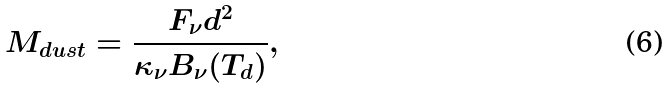Convert formula to latex. <formula><loc_0><loc_0><loc_500><loc_500>M _ { d u s t } = \frac { F _ { \nu } d ^ { 2 } } { \kappa _ { \nu } B _ { \nu } ( T _ { d } ) } ,</formula> 